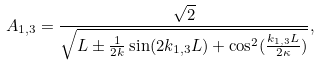<formula> <loc_0><loc_0><loc_500><loc_500>A _ { 1 , 3 } = \frac { \sqrt { 2 } } { \sqrt { L \pm \frac { 1 } { 2 k } \sin ( 2 k _ { 1 , 3 } L ) + \cos ^ { 2 } ( \frac { k _ { 1 , 3 } L } { 2 \kappa } ) } } ,</formula> 